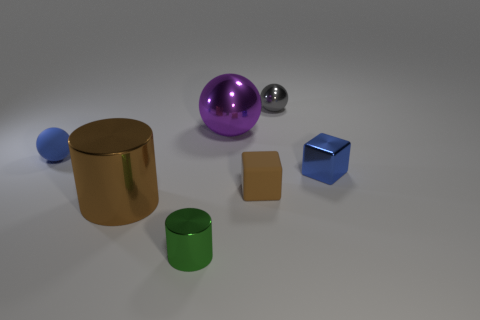What number of small things are to the left of the brown cube that is right of the large object that is behind the brown shiny object?
Provide a short and direct response. 2. There is a matte block that is the same size as the blue sphere; what is its color?
Ensure brevity in your answer.  Brown. What number of other objects are the same color as the big cylinder?
Keep it short and to the point. 1. Is the number of blue things in front of the blue block greater than the number of brown metal things?
Keep it short and to the point. No. Do the brown block and the brown cylinder have the same material?
Provide a short and direct response. No. What number of things are tiny shiny things behind the tiny rubber sphere or tiny yellow metal cylinders?
Your answer should be compact. 1. What number of other things are there of the same size as the blue block?
Provide a succinct answer. 4. Are there the same number of brown rubber blocks that are on the left side of the small rubber ball and gray shiny balls that are on the left side of the big brown shiny object?
Your response must be concise. Yes. What color is the other thing that is the same shape as the big brown thing?
Provide a succinct answer. Green. Is there any other thing that is the same shape as the small green metal object?
Your answer should be compact. Yes. 